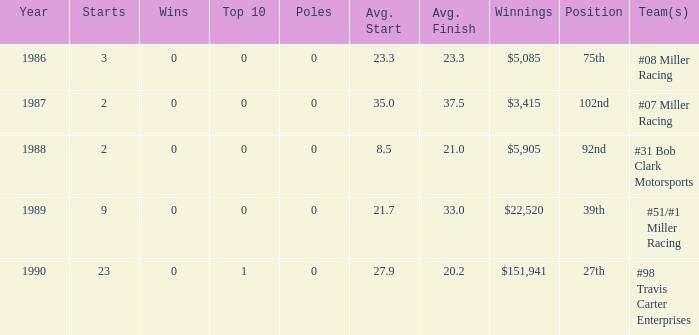5? 1988.0. 